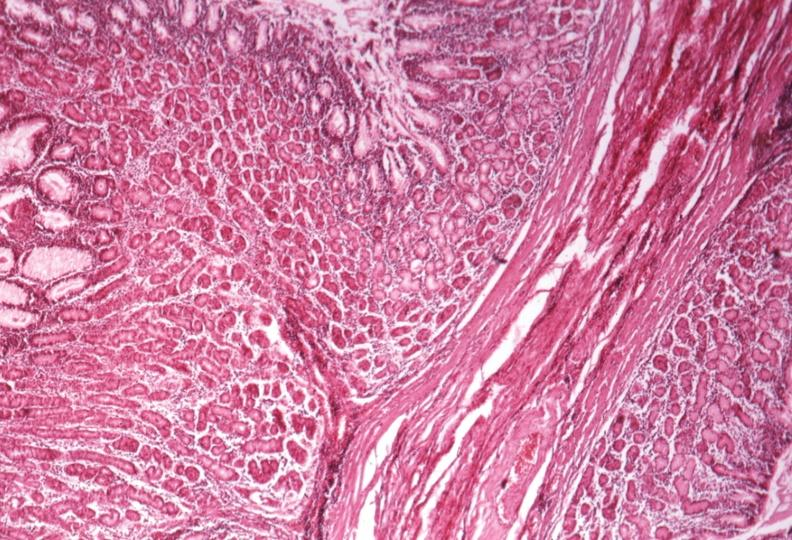what is present?
Answer the question using a single word or phrase. Hypertrophic gastritis 